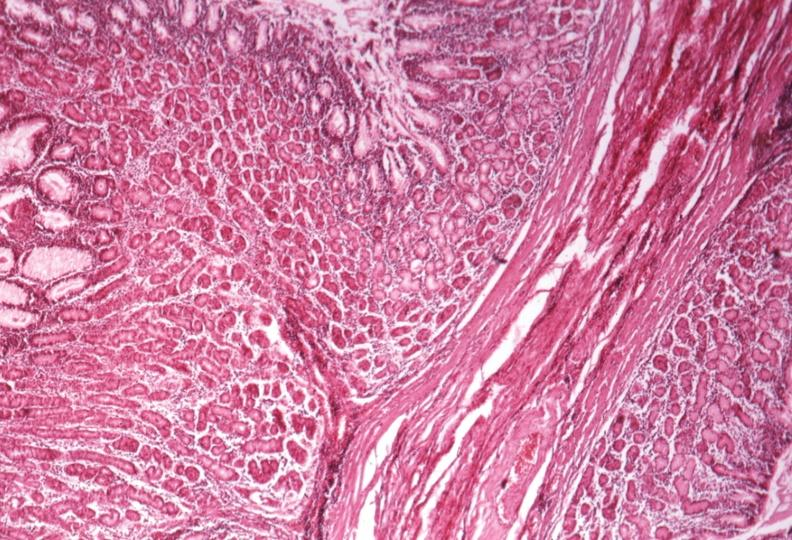what is present?
Answer the question using a single word or phrase. Hypertrophic gastritis 